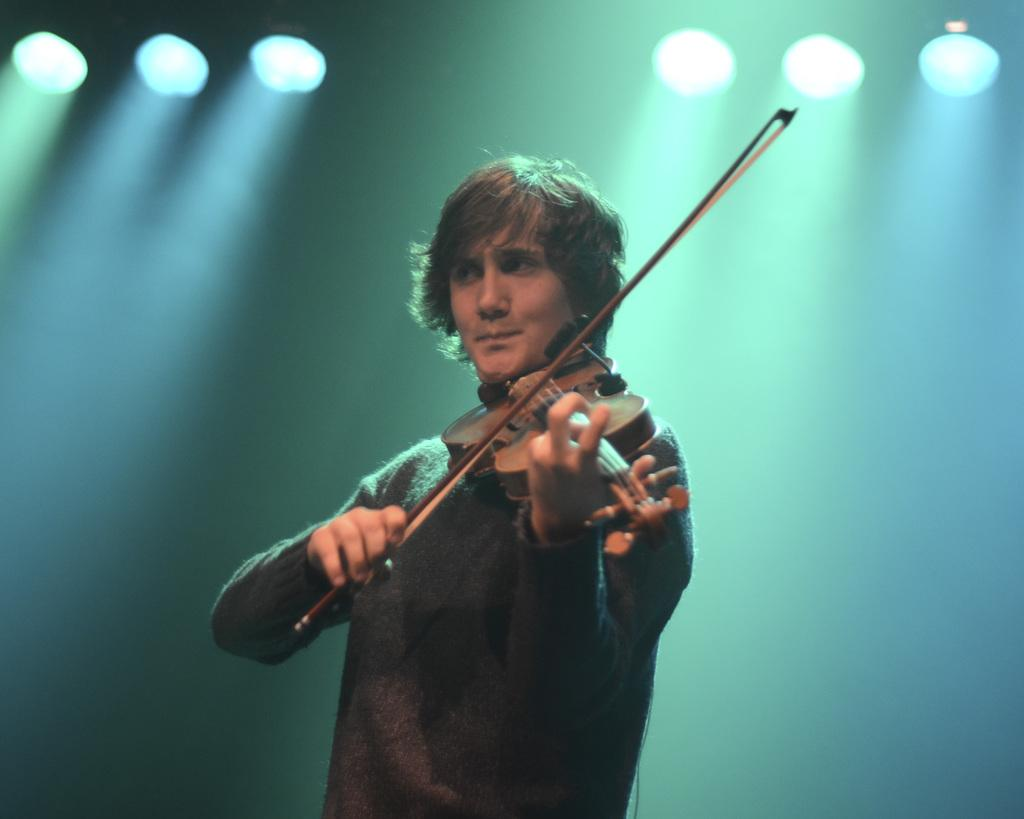What is the man in the image doing? The man is playing a guitar in the image. What can be seen in the background or surrounding the man? There are lights visible in the image. How does the man use the button to control the earthquake in the image? There is no button or earthquake present in the image; the man is simply playing a guitar. 